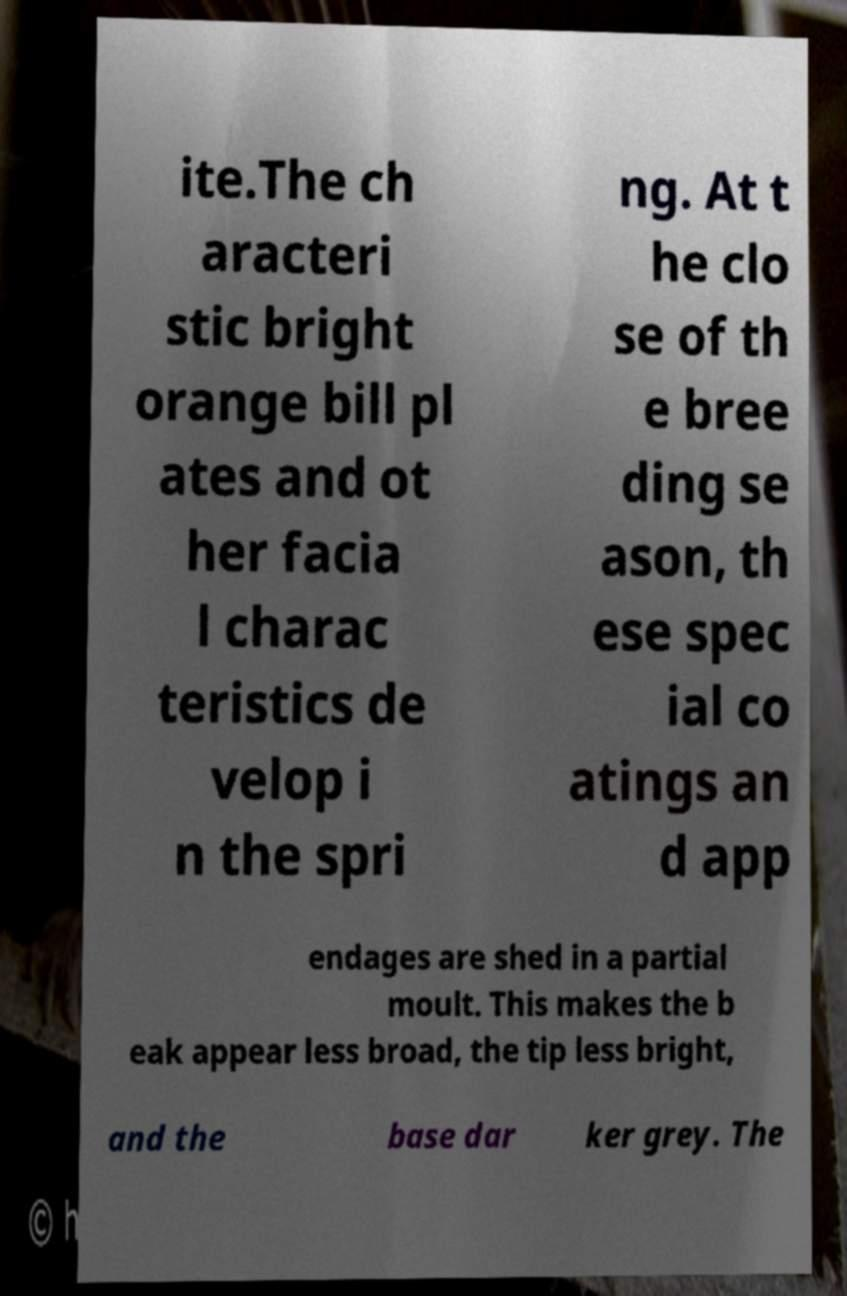Please identify and transcribe the text found in this image. ite.The ch aracteri stic bright orange bill pl ates and ot her facia l charac teristics de velop i n the spri ng. At t he clo se of th e bree ding se ason, th ese spec ial co atings an d app endages are shed in a partial moult. This makes the b eak appear less broad, the tip less bright, and the base dar ker grey. The 